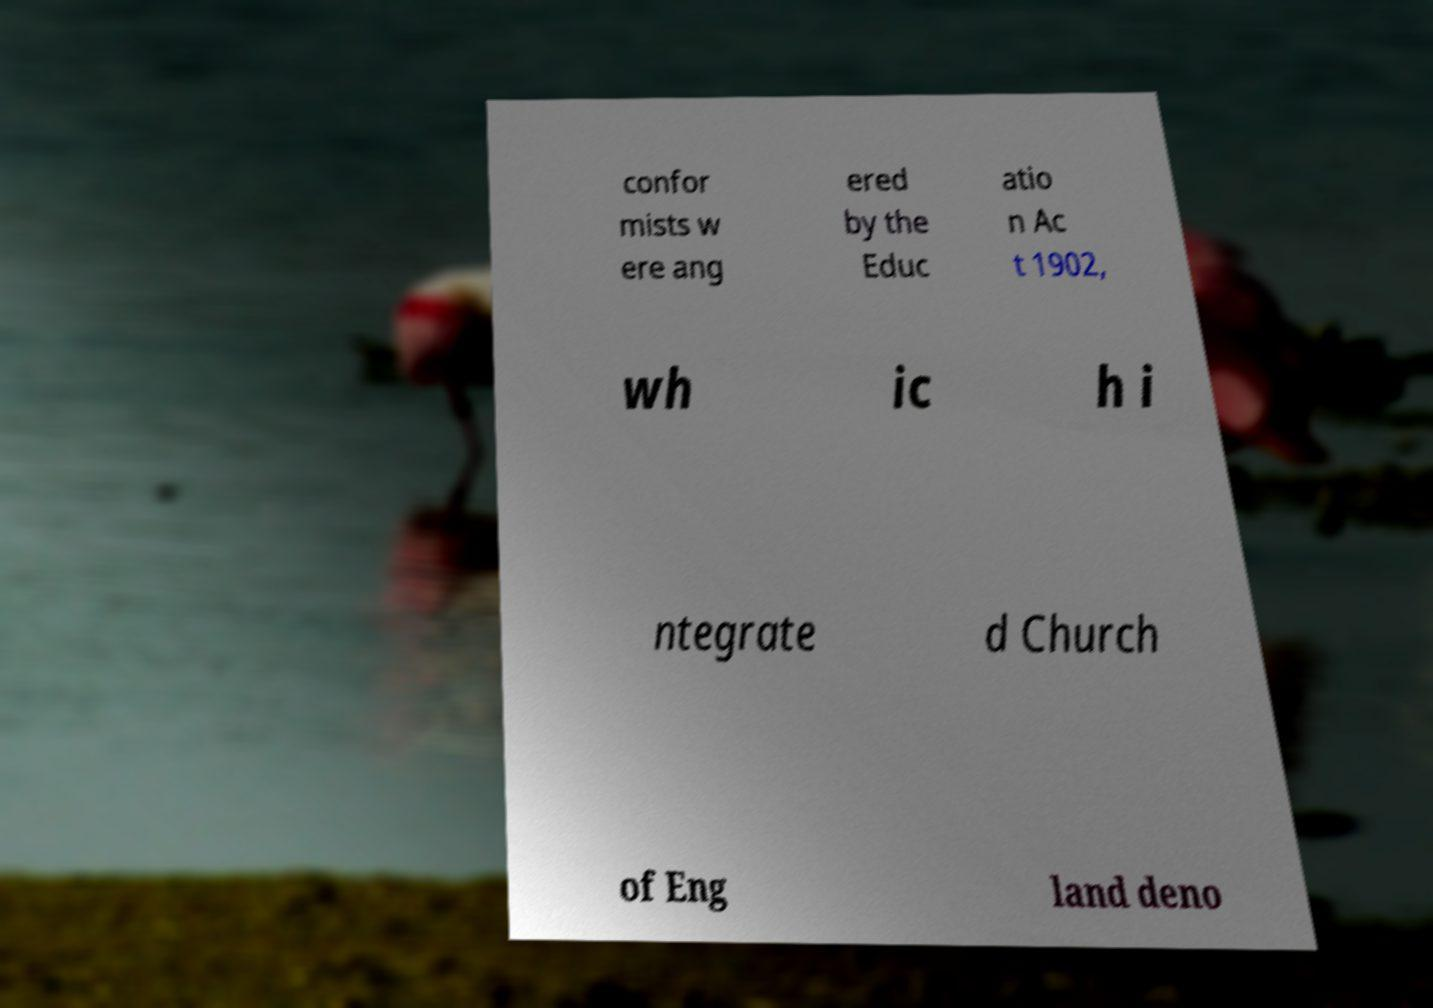Could you assist in decoding the text presented in this image and type it out clearly? confor mists w ere ang ered by the Educ atio n Ac t 1902, wh ic h i ntegrate d Church of Eng land deno 